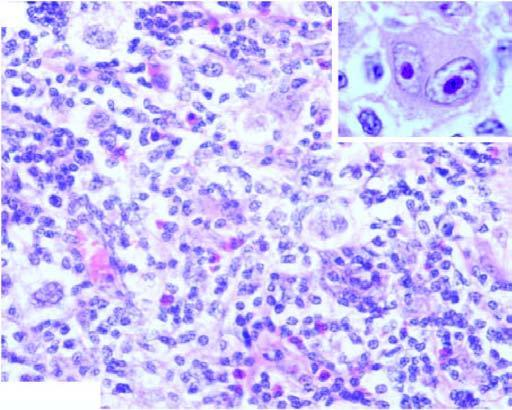re the apex bands of collagen forming nodules and characteristic lacunar rs cells?
Answer the question using a single word or phrase. No 